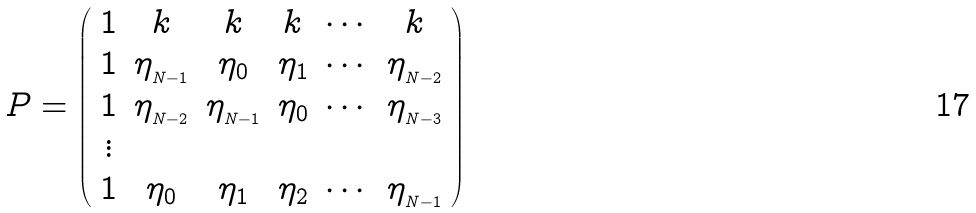Convert formula to latex. <formula><loc_0><loc_0><loc_500><loc_500>P = \left ( \begin{array} { c c c c c c } 1 & k & k & k & \cdots & k \\ 1 & \eta _ { _ { N - 1 } } & \eta _ { 0 } & \eta _ { 1 } & \cdots & \eta _ { _ { N - 2 } } \\ 1 & \eta _ { _ { N - 2 } } & \eta _ { _ { N - 1 } } & \eta _ { 0 } & \cdots & \eta _ { _ { N - 3 } } \\ \vdots & & & & \\ 1 & \eta _ { 0 } & \eta _ { 1 } & \eta _ { 2 } & \cdots & \eta _ { _ { N - 1 } } \\ \end{array} \right )</formula> 